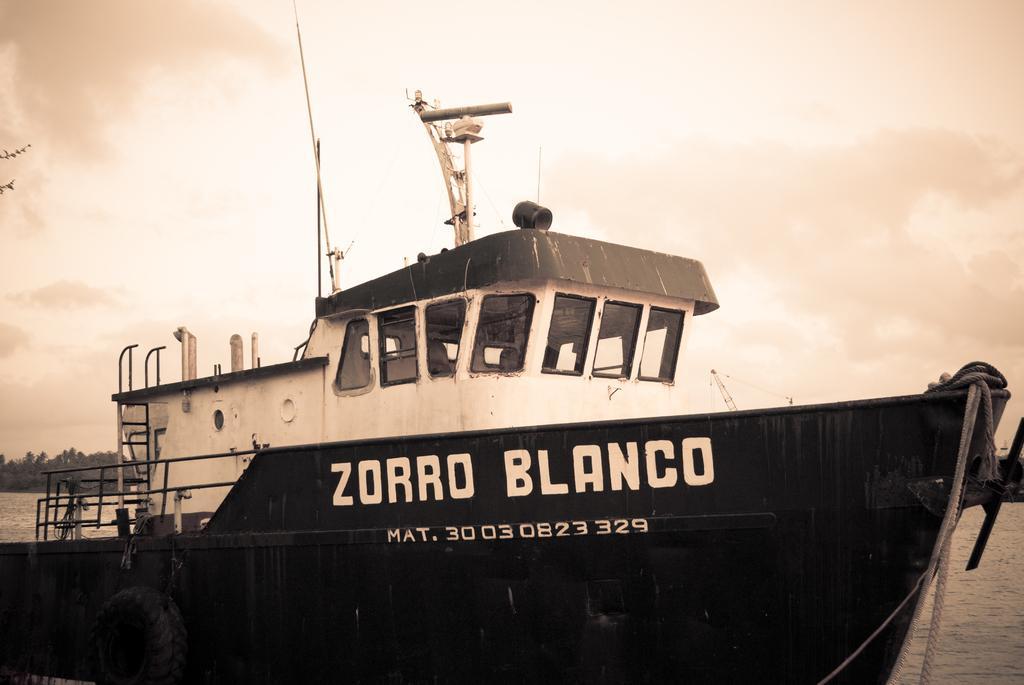Please provide a concise description of this image. In the middle of the image there is a ship above the water. Behind the ship there are some trees. Top of the image there are some clouds and sky. 